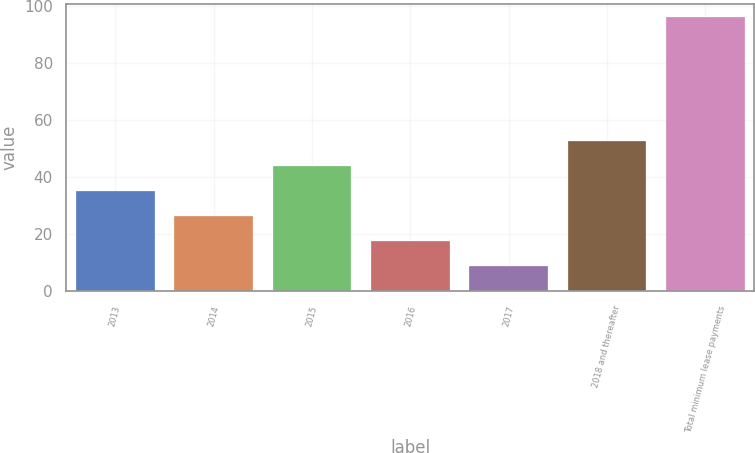Convert chart to OTSL. <chart><loc_0><loc_0><loc_500><loc_500><bar_chart><fcel>2013<fcel>2014<fcel>2015<fcel>2016<fcel>2017<fcel>2018 and thereafter<fcel>Total minimum lease payments<nl><fcel>35.1<fcel>26.4<fcel>43.8<fcel>17.7<fcel>9<fcel>52.5<fcel>96<nl></chart> 